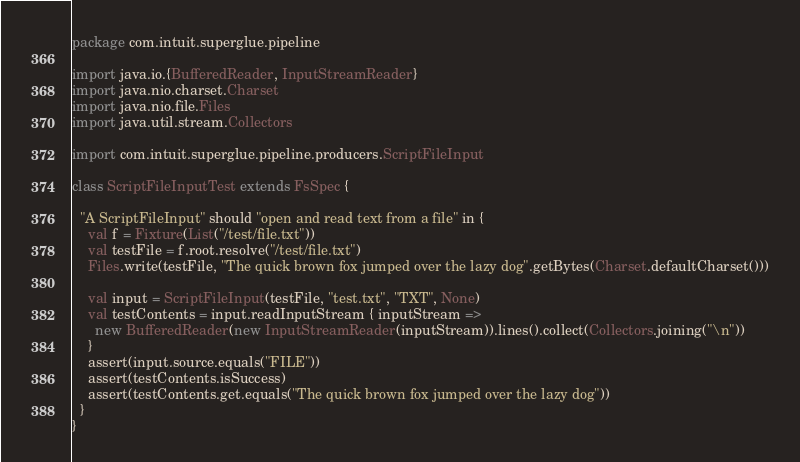<code> <loc_0><loc_0><loc_500><loc_500><_Scala_>package com.intuit.superglue.pipeline

import java.io.{BufferedReader, InputStreamReader}
import java.nio.charset.Charset
import java.nio.file.Files
import java.util.stream.Collectors

import com.intuit.superglue.pipeline.producers.ScriptFileInput

class ScriptFileInputTest extends FsSpec {

  "A ScriptFileInput" should "open and read text from a file" in {
    val f = Fixture(List("/test/file.txt"))
    val testFile = f.root.resolve("/test/file.txt")
    Files.write(testFile, "The quick brown fox jumped over the lazy dog".getBytes(Charset.defaultCharset()))

    val input = ScriptFileInput(testFile, "test.txt", "TXT", None)
    val testContents = input.readInputStream { inputStream =>
      new BufferedReader(new InputStreamReader(inputStream)).lines().collect(Collectors.joining("\n"))
    }
    assert(input.source.equals("FILE"))
    assert(testContents.isSuccess)
    assert(testContents.get.equals("The quick brown fox jumped over the lazy dog"))
  }
}
</code> 